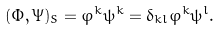<formula> <loc_0><loc_0><loc_500><loc_500>( \Phi , \Psi ) _ { S } = \varphi ^ { k } \psi ^ { k } = \delta _ { k l } \varphi ^ { k } \psi ^ { l } .</formula> 